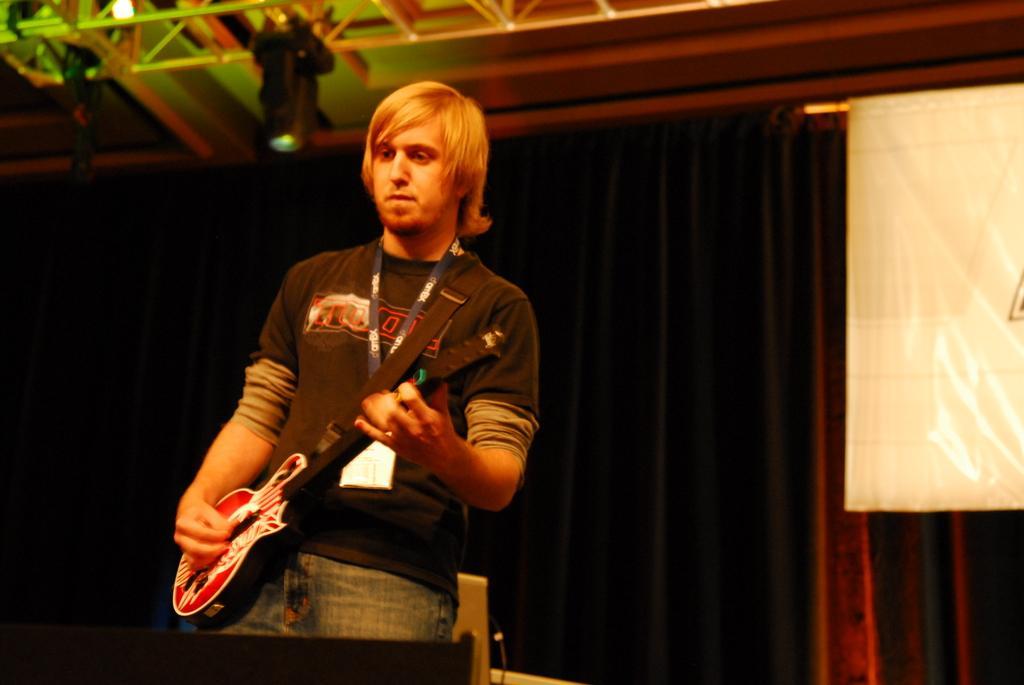How would you summarize this image in a sentence or two? Here we can see a man holding a guitar and playing a guitar and he is wearing an ID card and behind him we can see a black curtain and at the middle of right we can see a flag 